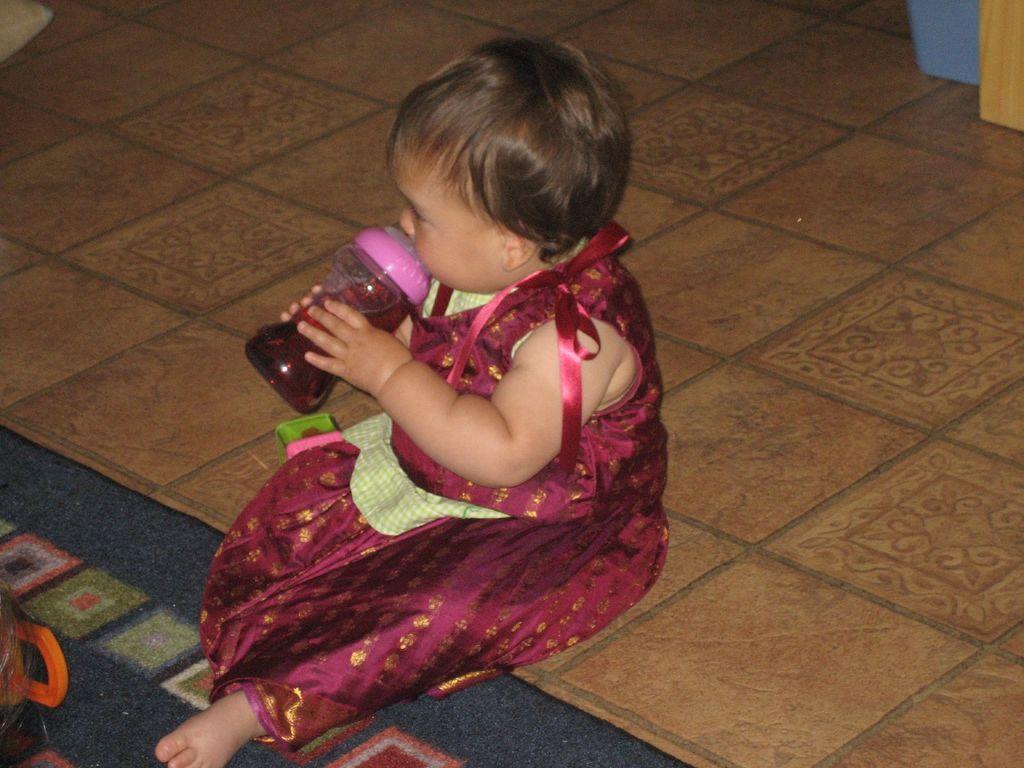Could you give a brief overview of what you see in this image? In the picture we can see floor with some brown color tiles and on it we can see a girl child sitting and drinking a juice with a bottle and near her legs we can see a mat which is blue in color. 